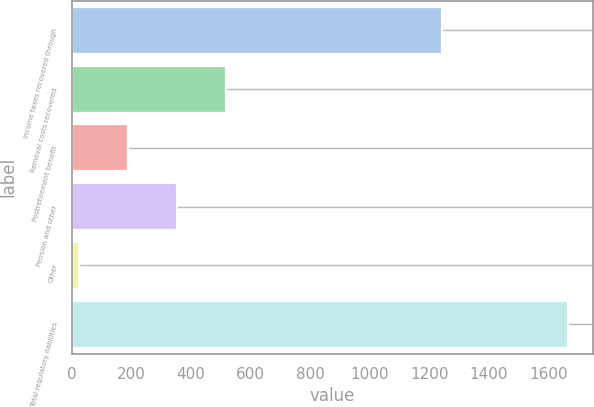Convert chart. <chart><loc_0><loc_0><loc_500><loc_500><bar_chart><fcel>Income taxes recovered through<fcel>Removal costs recovered<fcel>Postretirement benefit<fcel>Pension and other<fcel>Other<fcel>Total regulatory liabilities<nl><fcel>1242<fcel>517.4<fcel>189.8<fcel>353.6<fcel>26<fcel>1664<nl></chart> 